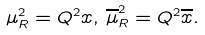<formula> <loc_0><loc_0><loc_500><loc_500>\mu _ { R } ^ { 2 } = Q ^ { 2 } x , \, \overline { \mu } _ { R } ^ { 2 } = Q ^ { 2 } \overline { x } .</formula> 